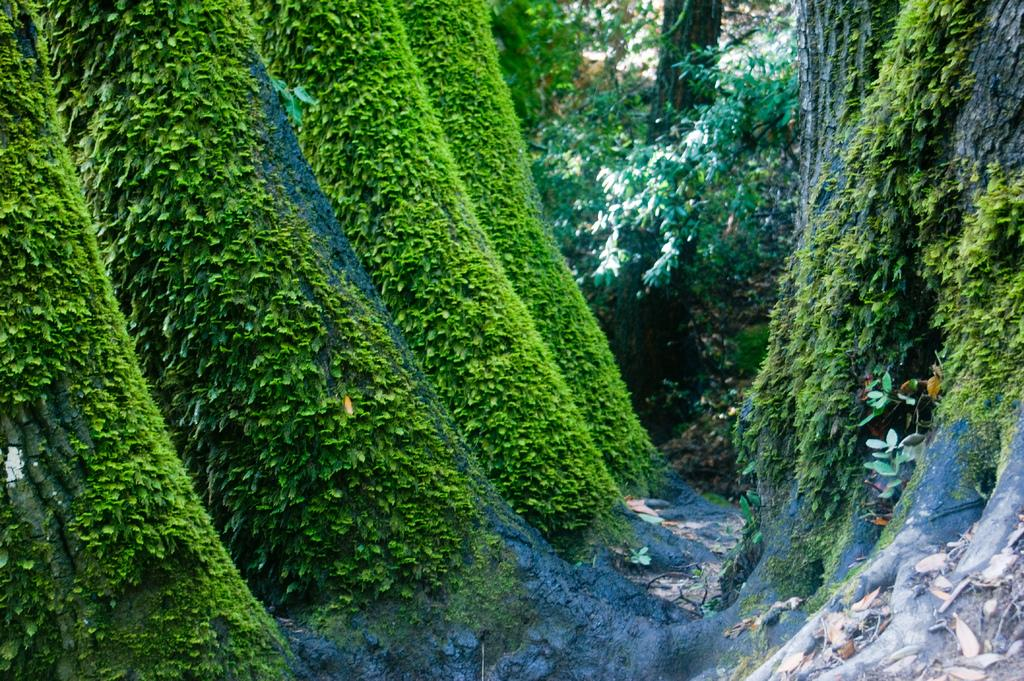What type of vegetation is in the center of the image? There are trees, plants, and grass in the center of the image. What else can be seen in the center of the image? Dry leaves are present in the center of the image. What company is responsible for the afterthought in the image? There is no company or afterthought present in the image; it features natural vegetation. Can you touch the trees in the image? The image is a visual representation, so you cannot physically touch the trees in the image. 